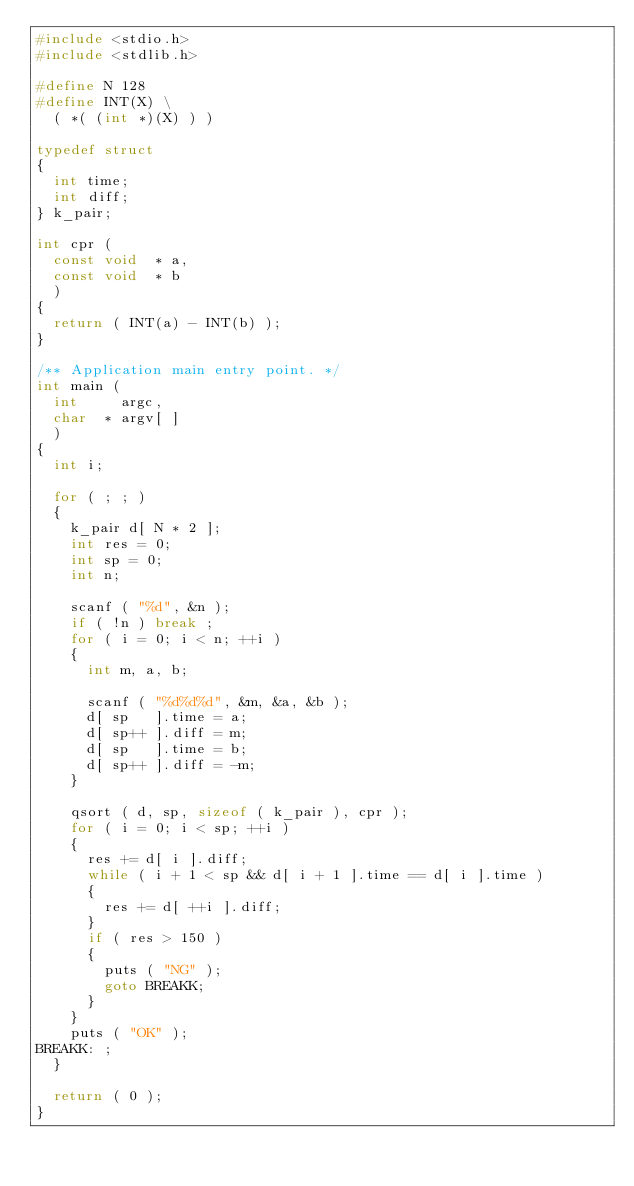Convert code to text. <code><loc_0><loc_0><loc_500><loc_500><_C_>#include <stdio.h>
#include <stdlib.h>

#define N 128
#define INT(X) \
  ( *( (int *)(X) ) )

typedef struct
{
  int time;
  int diff;
} k_pair;

int cpr (
  const void  * a,
  const void  * b
  )
{
  return ( INT(a) - INT(b) );
}

/** Application main entry point. */
int main (
  int     argc,
  char  * argv[ ]
  )
{
  int i;

  for ( ; ; )
  {
    k_pair d[ N * 2 ];
    int res = 0;
    int sp = 0;
    int n;

    scanf ( "%d", &n );
    if ( !n ) break ;
    for ( i = 0; i < n; ++i )
    {
      int m, a, b;

      scanf ( "%d%d%d", &m, &a, &b );
      d[ sp   ].time = a;
      d[ sp++ ].diff = m;
      d[ sp   ].time = b;
      d[ sp++ ].diff = -m;
    }

    qsort ( d, sp, sizeof ( k_pair ), cpr );
    for ( i = 0; i < sp; ++i )
    {
      res += d[ i ].diff;
      while ( i + 1 < sp && d[ i + 1 ].time == d[ i ].time )
      {
        res += d[ ++i ].diff;
      }
      if ( res > 150 )
      {
        puts ( "NG" );
        goto BREAKK;
      }
    }
    puts ( "OK" );
BREAKK: ;
  }

  return ( 0 );
}</code> 